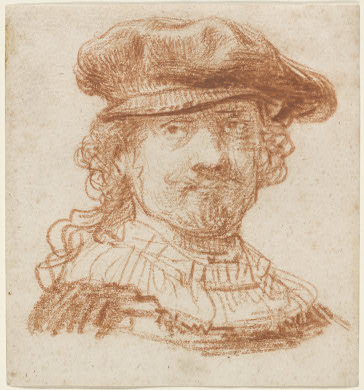Imagine if this portrait came to life and stepped out of the frame. How would he interact with the modern world? If this portrait came to life and stepped out of the frame, the figure might initially be puzzled by the modern world. He would likely be fascinated by the technology and fashion of today. With his regal attire and dignified presence, he might conduct himself with an air of authority and curiosity. He might engage in conversations about art, marvel at modern transportation like cars and airplanes, and perhaps share tales of his own era. Given his poised expression, he would likely adapt quickly, finding parallels between the past and present, and appreciating the advancements while providing a unique historical perspective to those around him. 